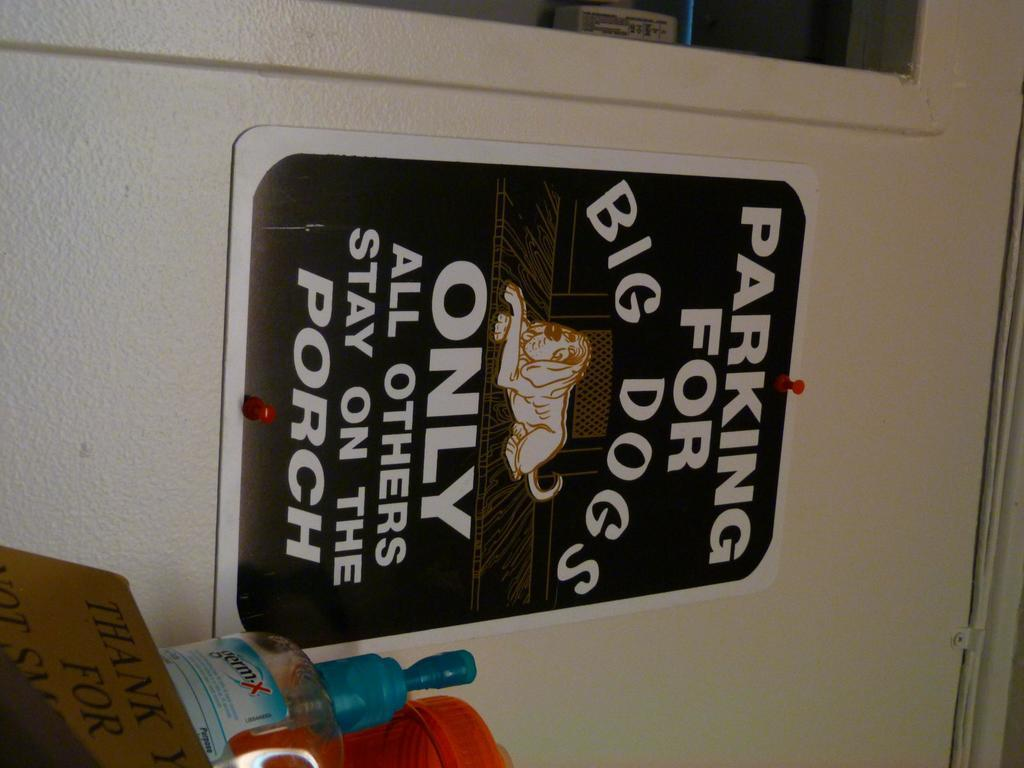What is the color of the wall in the image? The wall in the image is white. What is on the wall in the image? There is a poster on the wall in the image. What color is the poster on the wall? The poster on the wall is in black color. What objects are beside the poster on the wall? There is a card, a bottle, and a jar beside the poster on the wall. How many cherries are resting on the white wall in the image? There are no cherries present in the image. What type of pail is used to collect water from the jar in the image? There is no pail or jar being used to collect water in the image. 